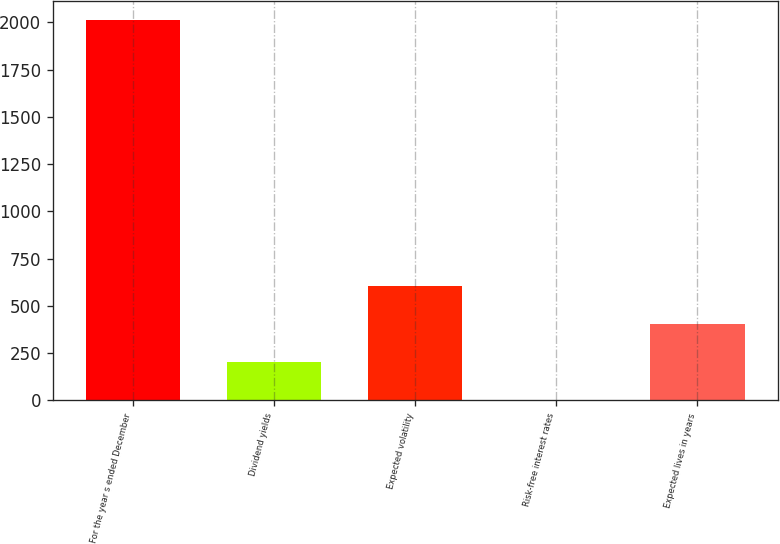Convert chart. <chart><loc_0><loc_0><loc_500><loc_500><bar_chart><fcel>For the year s ended December<fcel>Dividend yields<fcel>Expected volatility<fcel>Risk-free interest rates<fcel>Expected lives in years<nl><fcel>2012<fcel>202.55<fcel>604.65<fcel>1.5<fcel>403.6<nl></chart> 